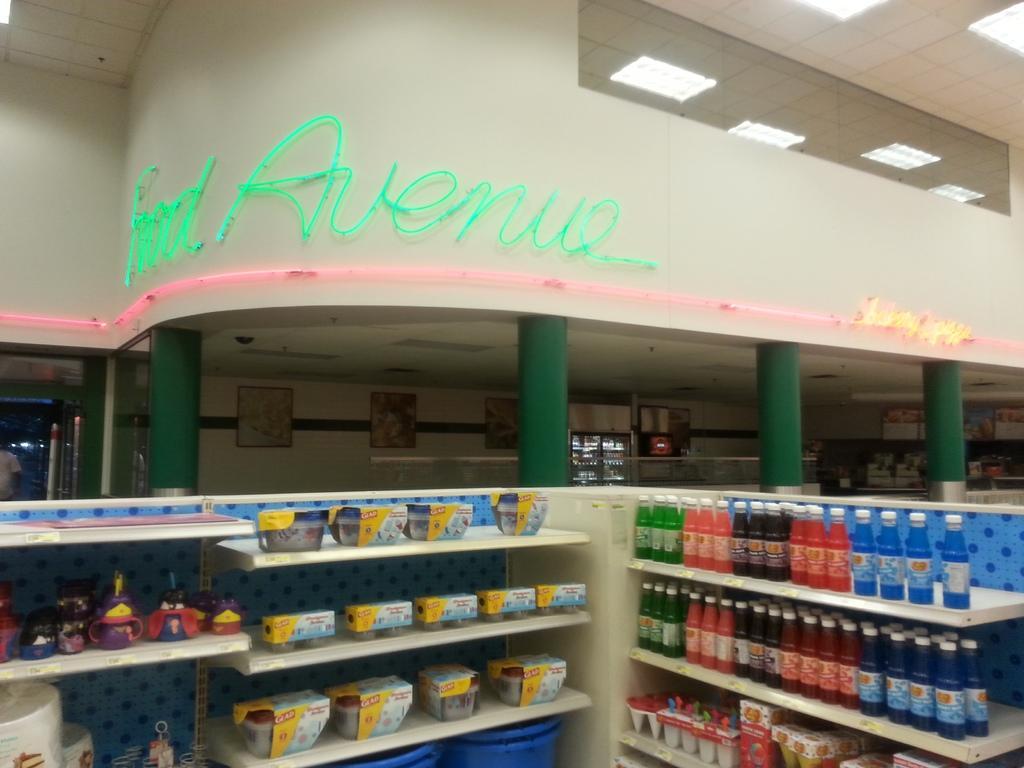Can you describe this image briefly? In this image we can see a building with pillars, some frames on a wall and ceiling lights to a roof. On the bottom of the image we can see a group of bottles, toys and some books which are placed in the shelves. We can also see a person standing. 